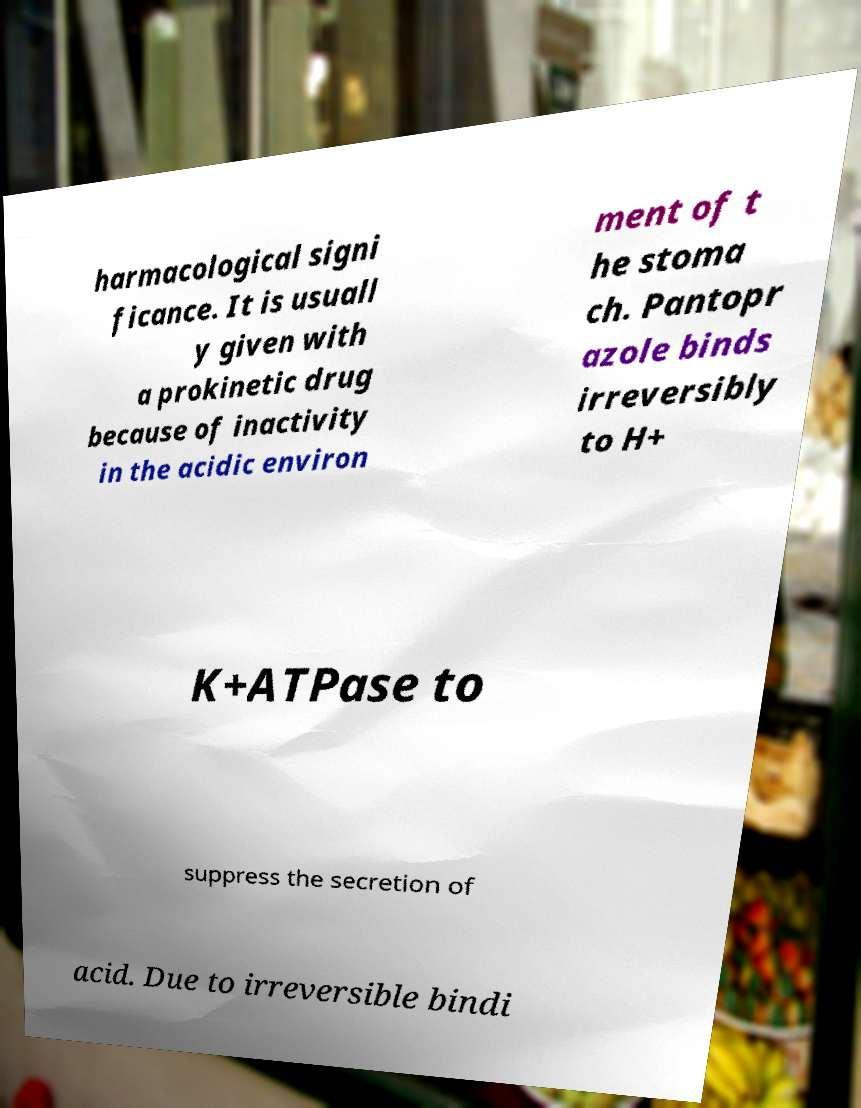Can you accurately transcribe the text from the provided image for me? harmacological signi ficance. It is usuall y given with a prokinetic drug because of inactivity in the acidic environ ment of t he stoma ch. Pantopr azole binds irreversibly to H+ K+ATPase to suppress the secretion of acid. Due to irreversible bindi 